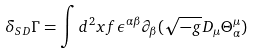<formula> <loc_0><loc_0><loc_500><loc_500>\delta _ { S D } \Gamma = \int d ^ { 2 } x f \epsilon ^ { \alpha \beta } \partial _ { \beta } ( \sqrt { - g } D _ { \mu } \Theta _ { \alpha } ^ { \mu } )</formula> 